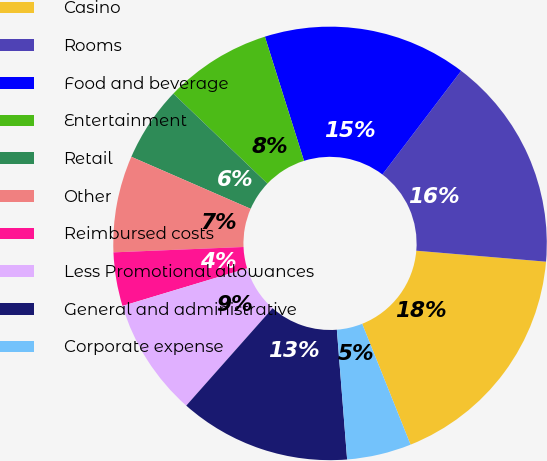Convert chart. <chart><loc_0><loc_0><loc_500><loc_500><pie_chart><fcel>Casino<fcel>Rooms<fcel>Food and beverage<fcel>Entertainment<fcel>Retail<fcel>Other<fcel>Reimbursed costs<fcel>Less Promotional allowances<fcel>General and administrative<fcel>Corporate expense<nl><fcel>17.6%<fcel>16.0%<fcel>15.2%<fcel>8.0%<fcel>5.6%<fcel>7.2%<fcel>4.0%<fcel>8.8%<fcel>12.8%<fcel>4.8%<nl></chart> 